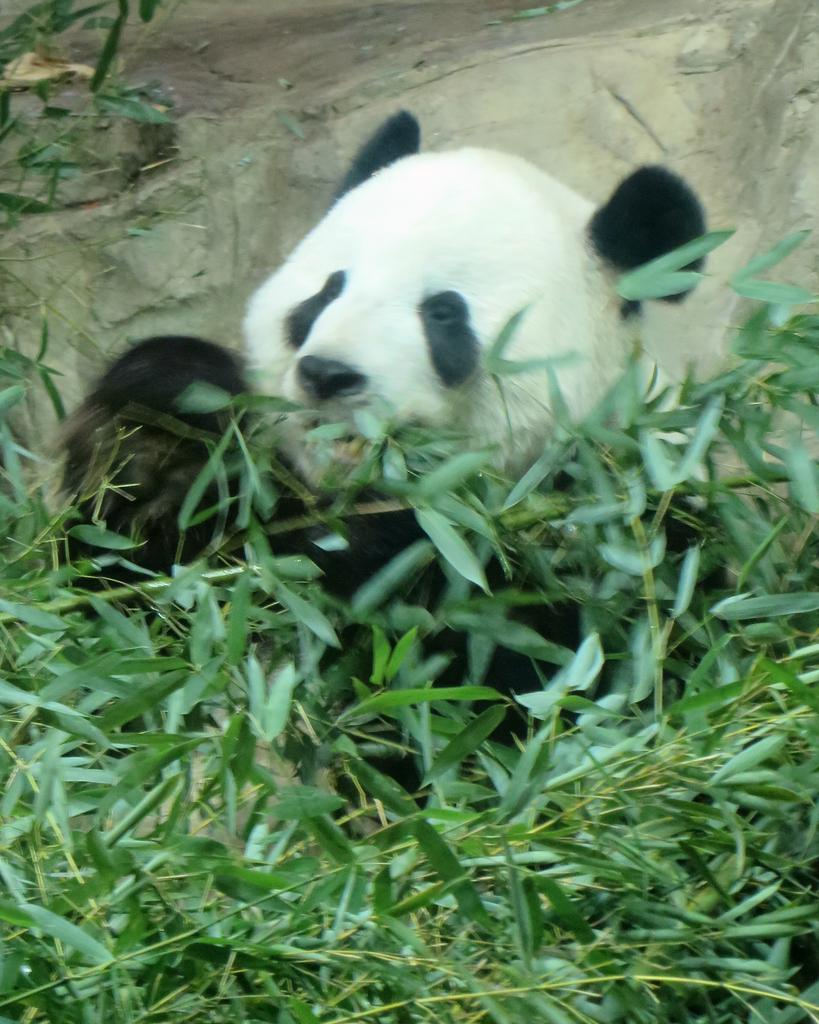What is the primary element in the image? There are many leaves in the image. How are the leaves connected to the stems? The leaves are attached to stems in the image. Can you describe the background of the image? There is a panda behind the stems in the image. What type of mask is the panda wearing in the image? There is no mask present in the image; the panda is not wearing any mask. 